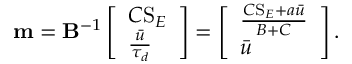Convert formula to latex. <formula><loc_0><loc_0><loc_500><loc_500>m = B ^ { - 1 } \left [ \begin{array} { l } { C S _ { E } } \\ { \frac { \bar { u } } { \tau _ { d } } } \end{array} \right ] = \left [ \begin{array} { l } { \frac { C S _ { E } + a \bar { u } } { B + C } } \\ { \bar { u } } \end{array} \right ] .</formula> 